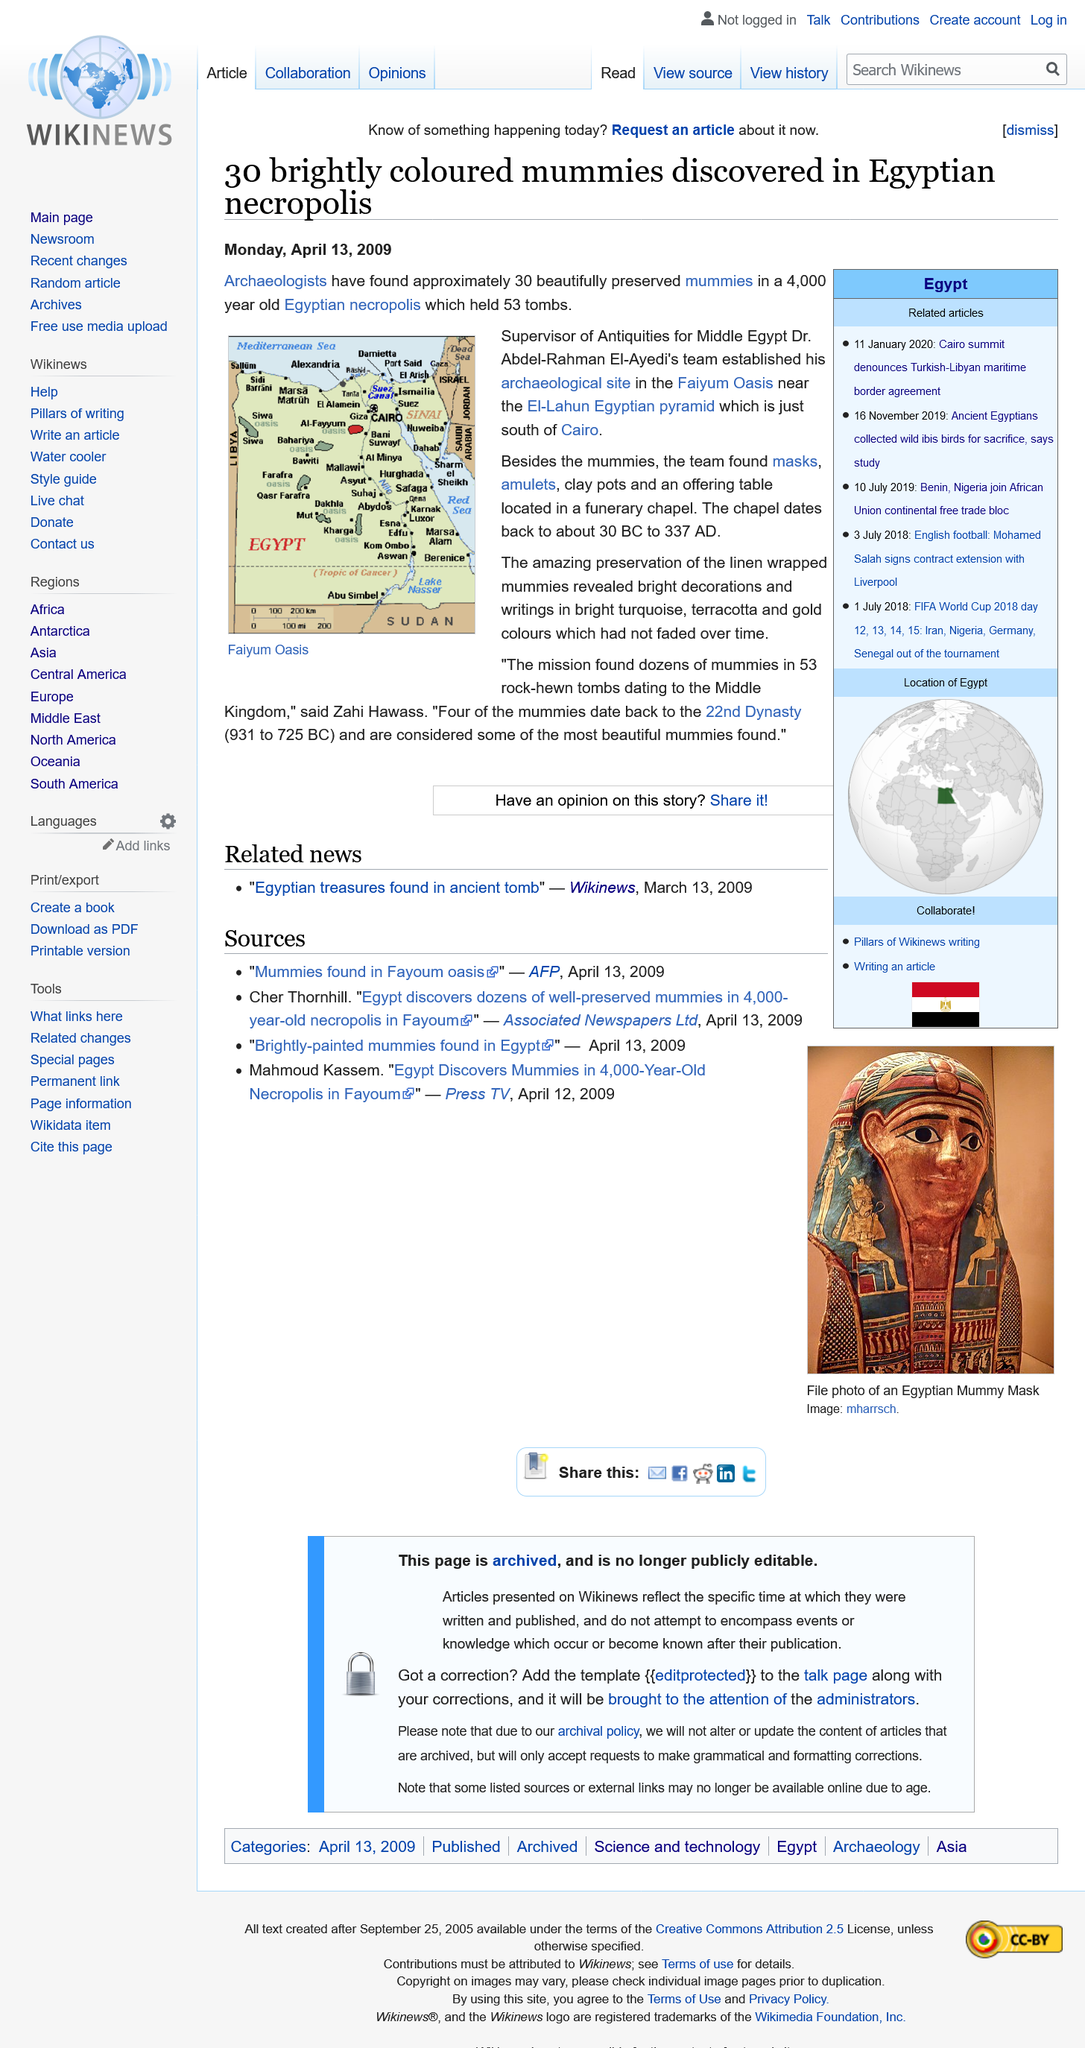Identify some key points in this picture. Dr. Abdel-Rahman El-Ayed The map depicts the Faiyum Oasis. The El-Lahub Egyptian Pyramid is located in Egypt, south of Cairo, and is a well-known landmark. 